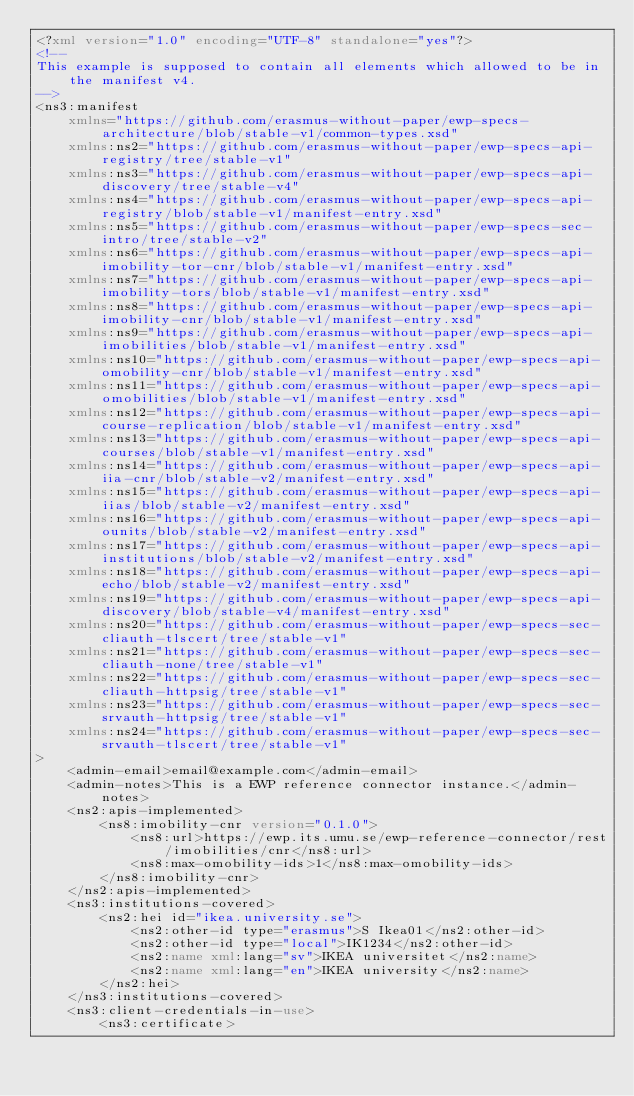Convert code to text. <code><loc_0><loc_0><loc_500><loc_500><_XML_><?xml version="1.0" encoding="UTF-8" standalone="yes"?>
<!--
This example is supposed to contain all elements which allowed to be in the manifest v4.
-->
<ns3:manifest
    xmlns="https://github.com/erasmus-without-paper/ewp-specs-architecture/blob/stable-v1/common-types.xsd"
    xmlns:ns2="https://github.com/erasmus-without-paper/ewp-specs-api-registry/tree/stable-v1"
    xmlns:ns3="https://github.com/erasmus-without-paper/ewp-specs-api-discovery/tree/stable-v4"
    xmlns:ns4="https://github.com/erasmus-without-paper/ewp-specs-api-registry/blob/stable-v1/manifest-entry.xsd"
    xmlns:ns5="https://github.com/erasmus-without-paper/ewp-specs-sec-intro/tree/stable-v2"
    xmlns:ns6="https://github.com/erasmus-without-paper/ewp-specs-api-imobility-tor-cnr/blob/stable-v1/manifest-entry.xsd"
    xmlns:ns7="https://github.com/erasmus-without-paper/ewp-specs-api-imobility-tors/blob/stable-v1/manifest-entry.xsd"
    xmlns:ns8="https://github.com/erasmus-without-paper/ewp-specs-api-imobility-cnr/blob/stable-v1/manifest-entry.xsd"
    xmlns:ns9="https://github.com/erasmus-without-paper/ewp-specs-api-imobilities/blob/stable-v1/manifest-entry.xsd"
    xmlns:ns10="https://github.com/erasmus-without-paper/ewp-specs-api-omobility-cnr/blob/stable-v1/manifest-entry.xsd"
    xmlns:ns11="https://github.com/erasmus-without-paper/ewp-specs-api-omobilities/blob/stable-v1/manifest-entry.xsd"
    xmlns:ns12="https://github.com/erasmus-without-paper/ewp-specs-api-course-replication/blob/stable-v1/manifest-entry.xsd"
    xmlns:ns13="https://github.com/erasmus-without-paper/ewp-specs-api-courses/blob/stable-v1/manifest-entry.xsd"
    xmlns:ns14="https://github.com/erasmus-without-paper/ewp-specs-api-iia-cnr/blob/stable-v2/manifest-entry.xsd"
    xmlns:ns15="https://github.com/erasmus-without-paper/ewp-specs-api-iias/blob/stable-v2/manifest-entry.xsd"
    xmlns:ns16="https://github.com/erasmus-without-paper/ewp-specs-api-ounits/blob/stable-v2/manifest-entry.xsd"
    xmlns:ns17="https://github.com/erasmus-without-paper/ewp-specs-api-institutions/blob/stable-v2/manifest-entry.xsd"
    xmlns:ns18="https://github.com/erasmus-without-paper/ewp-specs-api-echo/blob/stable-v2/manifest-entry.xsd"
    xmlns:ns19="https://github.com/erasmus-without-paper/ewp-specs-api-discovery/blob/stable-v4/manifest-entry.xsd"
    xmlns:ns20="https://github.com/erasmus-without-paper/ewp-specs-sec-cliauth-tlscert/tree/stable-v1"
    xmlns:ns21="https://github.com/erasmus-without-paper/ewp-specs-sec-cliauth-none/tree/stable-v1"
    xmlns:ns22="https://github.com/erasmus-without-paper/ewp-specs-sec-cliauth-httpsig/tree/stable-v1"
    xmlns:ns23="https://github.com/erasmus-without-paper/ewp-specs-sec-srvauth-httpsig/tree/stable-v1"
    xmlns:ns24="https://github.com/erasmus-without-paper/ewp-specs-sec-srvauth-tlscert/tree/stable-v1"
>
    <admin-email>email@example.com</admin-email>
    <admin-notes>This is a EWP reference connector instance.</admin-notes>
    <ns2:apis-implemented>
        <ns8:imobility-cnr version="0.1.0">
            <ns8:url>https://ewp.its.umu.se/ewp-reference-connector/rest/imobilities/cnr</ns8:url>
            <ns8:max-omobility-ids>1</ns8:max-omobility-ids>
        </ns8:imobility-cnr>
    </ns2:apis-implemented>
    <ns3:institutions-covered>
        <ns2:hei id="ikea.university.se">
            <ns2:other-id type="erasmus">S Ikea01</ns2:other-id>
            <ns2:other-id type="local">IK1234</ns2:other-id>
            <ns2:name xml:lang="sv">IKEA universitet</ns2:name>
            <ns2:name xml:lang="en">IKEA university</ns2:name>
        </ns2:hei>
    </ns3:institutions-covered>
    <ns3:client-credentials-in-use>
        <ns3:certificate></code> 